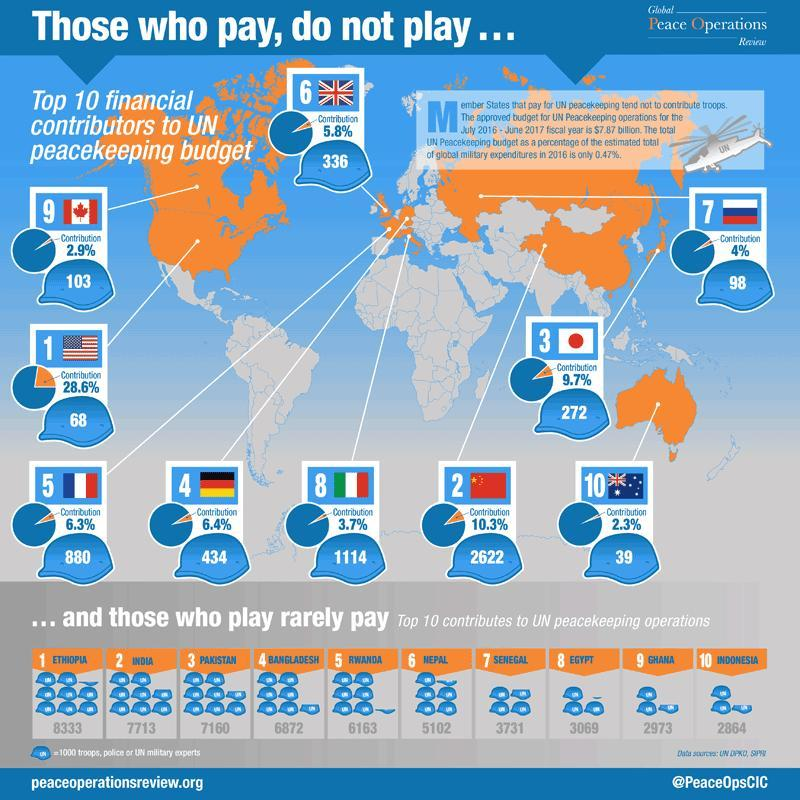What is the contribution of US in terms of troops to the UN peacekeeping?
Answer the question with a short phrase. 68 How many more troops does Pakistan contribute to UN peace keeping operations in comparison to Bangladesh? 288 Which country is the lowest contributor for troops as well as funds? Australia What is the percentage difference in contribution between Japan and the UK to the UN peacekeeping budget? 3.9% What is the second highest contribution of troops to the UN peace keeping operations? 7713 